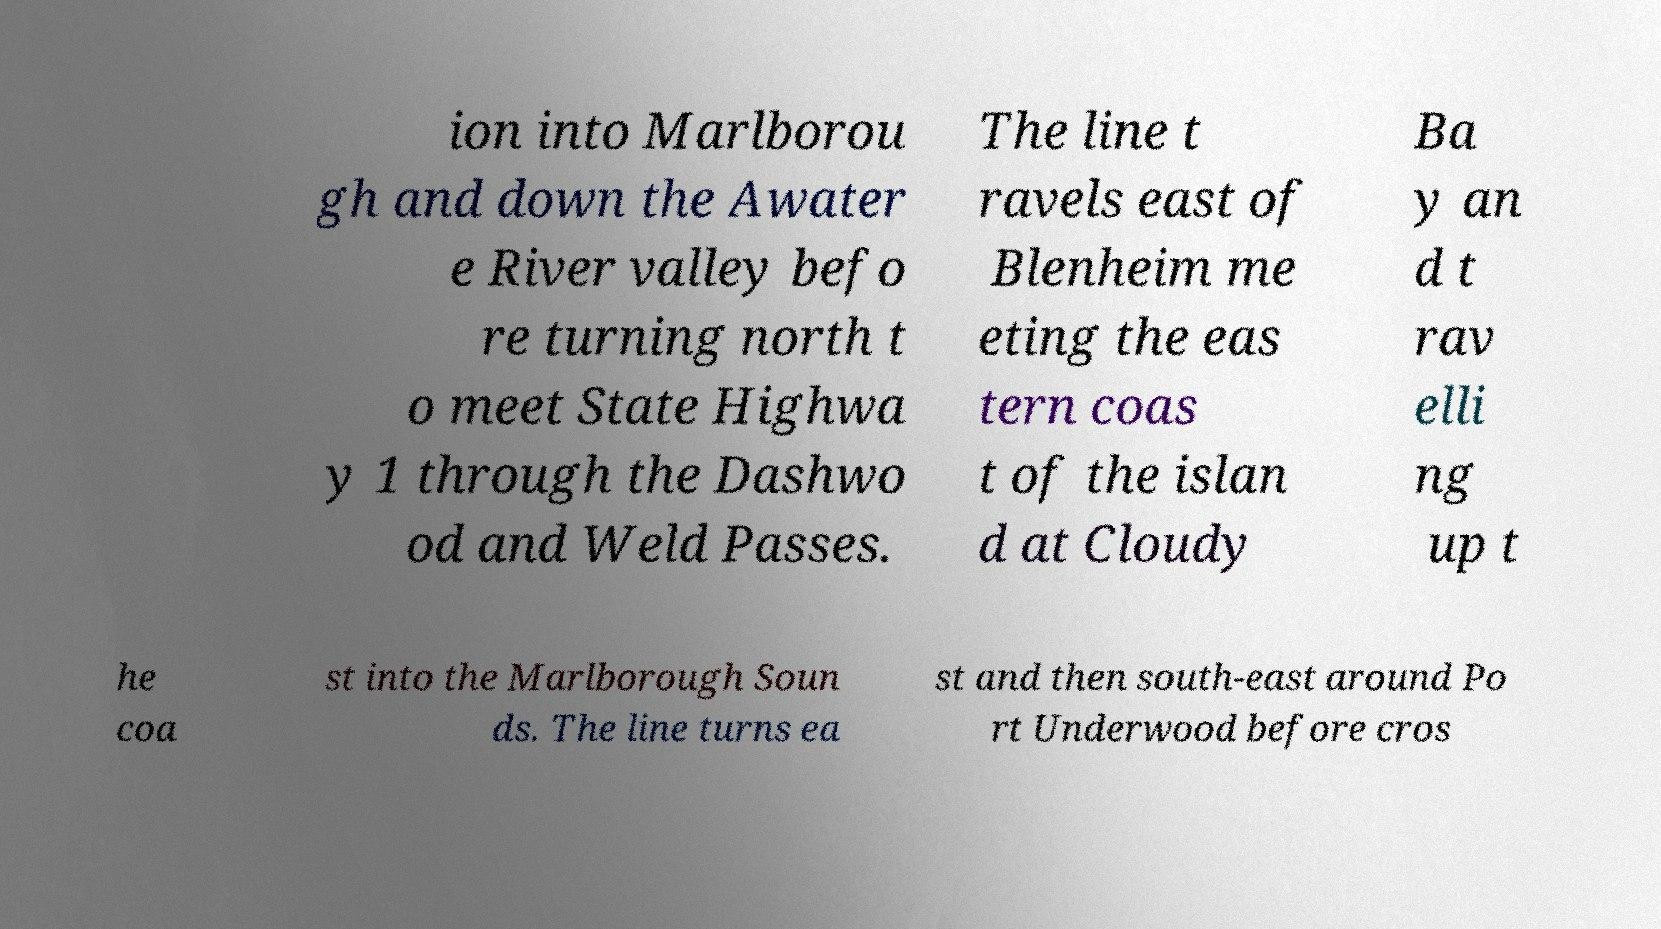Could you extract and type out the text from this image? ion into Marlborou gh and down the Awater e River valley befo re turning north t o meet State Highwa y 1 through the Dashwo od and Weld Passes. The line t ravels east of Blenheim me eting the eas tern coas t of the islan d at Cloudy Ba y an d t rav elli ng up t he coa st into the Marlborough Soun ds. The line turns ea st and then south-east around Po rt Underwood before cros 